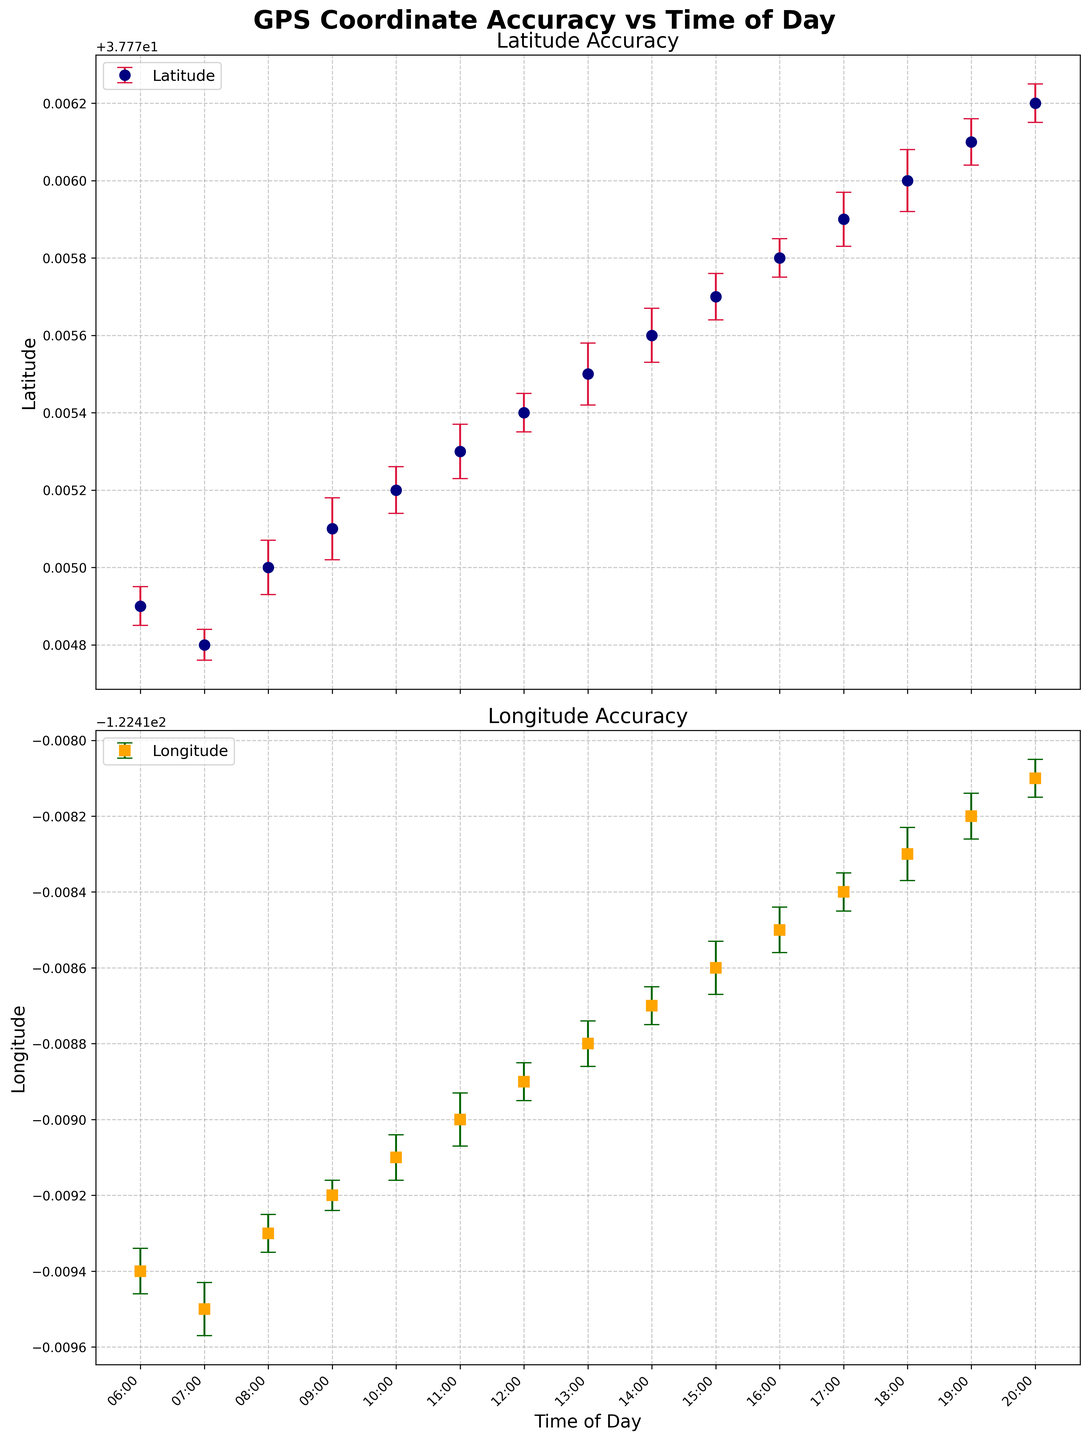What does the top graph's y-axis represent? The y-axis label on the top graph indicates that it represents the Latitude, showing the accuracy of latitude measurements.
Answer: Latitude Which period shows the highest error variability in longitude? The error bars indicate the signal variability, and the longest error bars for longitude are seen around 07:00 and 18:00, indicating higher error variability during these times.
Answer: 07:00 and 18:00 How many data points are plotted on the longitude graph? Each hour from 06:00 to 20:00 has a corresponding data point on the graph. Counting the listed times, there are 15 data points in total.
Answer: 15 At what time of day is the latitude mean the lowest? By examining the latitude means plotted on the top graph, the lowest latitude value appears to be at 07:00.
Answer: 07:00 What is the trend for longitude accuracy over the course of the day? Observing the mean longitude values over time, there is a general trend where the longitude becomes more positive, indicating an overall increase.
Answer: It increases What's the difference in latitude error variability between 09:00 and 15:00? The latitude error at 09:00 is 0.00008 while at 15:00 it is 0.00006. The difference is calculated as 0.00008 - 0.00006 = 0.00002.
Answer: 0.00002 Which time of day has the smallest error bar for latitude? By inspecting the error bars for latitude, the smallest error bar is visible at 07:00.
Answer: 07:00 What is the average of the mean longitude values at 06:00, 12:00, and 18:00? The mean longitude values at 06:00, 12:00, and 18:00 are -122.4194, -122.4189, and -122.4183 respectively. The average is calculated as (-122.4194 - 122.4189 - 122.4183)/3 = -122.41887.
Answer: -122.41887 Between what times does the latitude seem to be the most stable? The latitude appears most stable from 12:00 to 16:00 as both the mean values are close together and the error bars are smaller during this period.
Answer: 12:00 to 16:00 